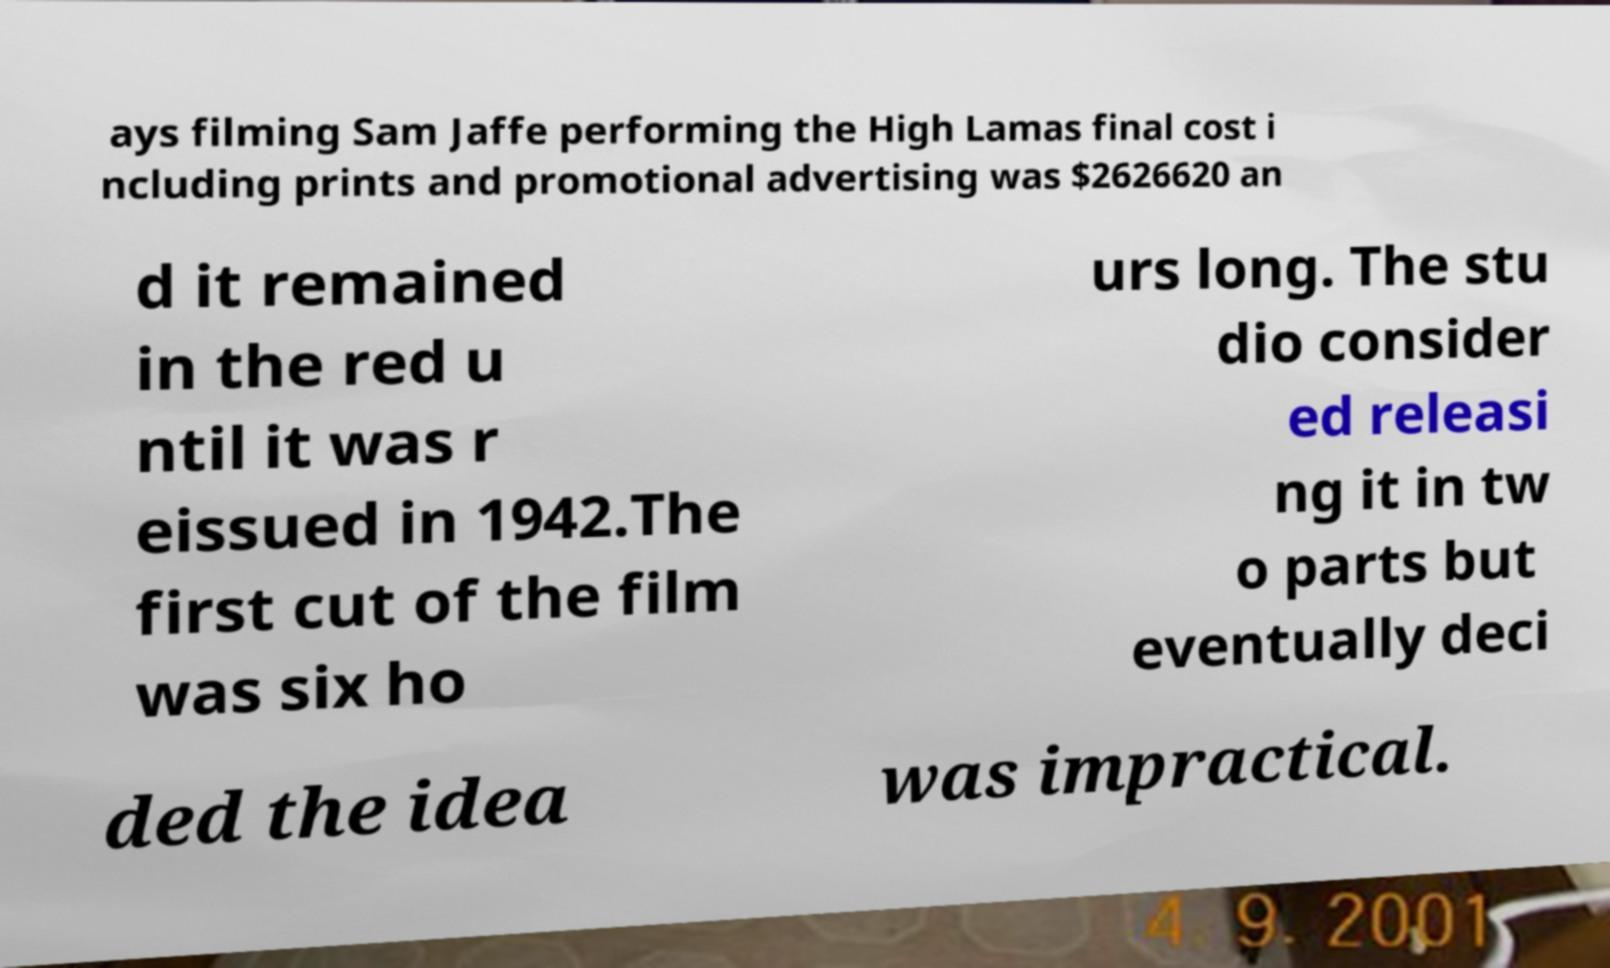Could you assist in decoding the text presented in this image and type it out clearly? ays filming Sam Jaffe performing the High Lamas final cost i ncluding prints and promotional advertising was $2626620 an d it remained in the red u ntil it was r eissued in 1942.The first cut of the film was six ho urs long. The stu dio consider ed releasi ng it in tw o parts but eventually deci ded the idea was impractical. 